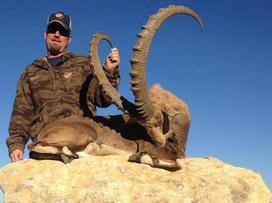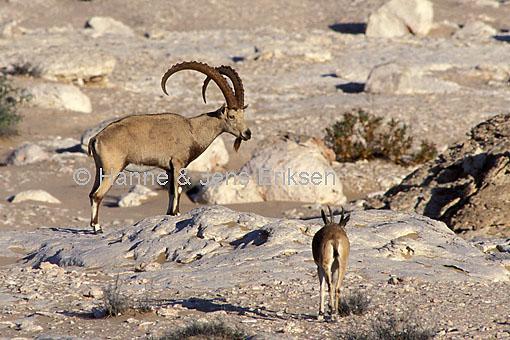The first image is the image on the left, the second image is the image on the right. Examine the images to the left and right. Is the description "A hunter is touching an ibex's horns." accurate? Answer yes or no. Yes. The first image is the image on the left, the second image is the image on the right. Considering the images on both sides, is "An image shows one man in a hat behind a downed animal, holding onto the tip of one horn with his hand." valid? Answer yes or no. Yes. 